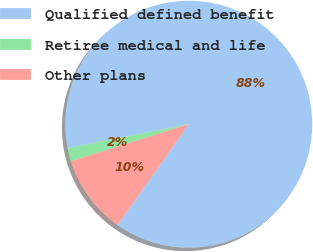Convert chart. <chart><loc_0><loc_0><loc_500><loc_500><pie_chart><fcel>Qualified defined benefit<fcel>Retiree medical and life<fcel>Other plans<nl><fcel>87.9%<fcel>1.74%<fcel>10.36%<nl></chart> 